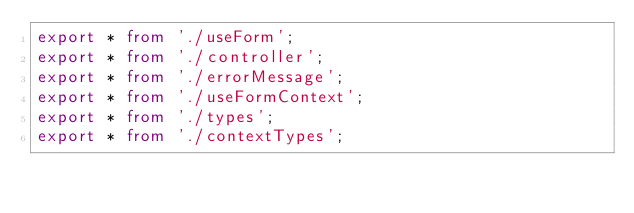<code> <loc_0><loc_0><loc_500><loc_500><_TypeScript_>export * from './useForm';
export * from './controller';
export * from './errorMessage';
export * from './useFormContext';
export * from './types';
export * from './contextTypes';
</code> 